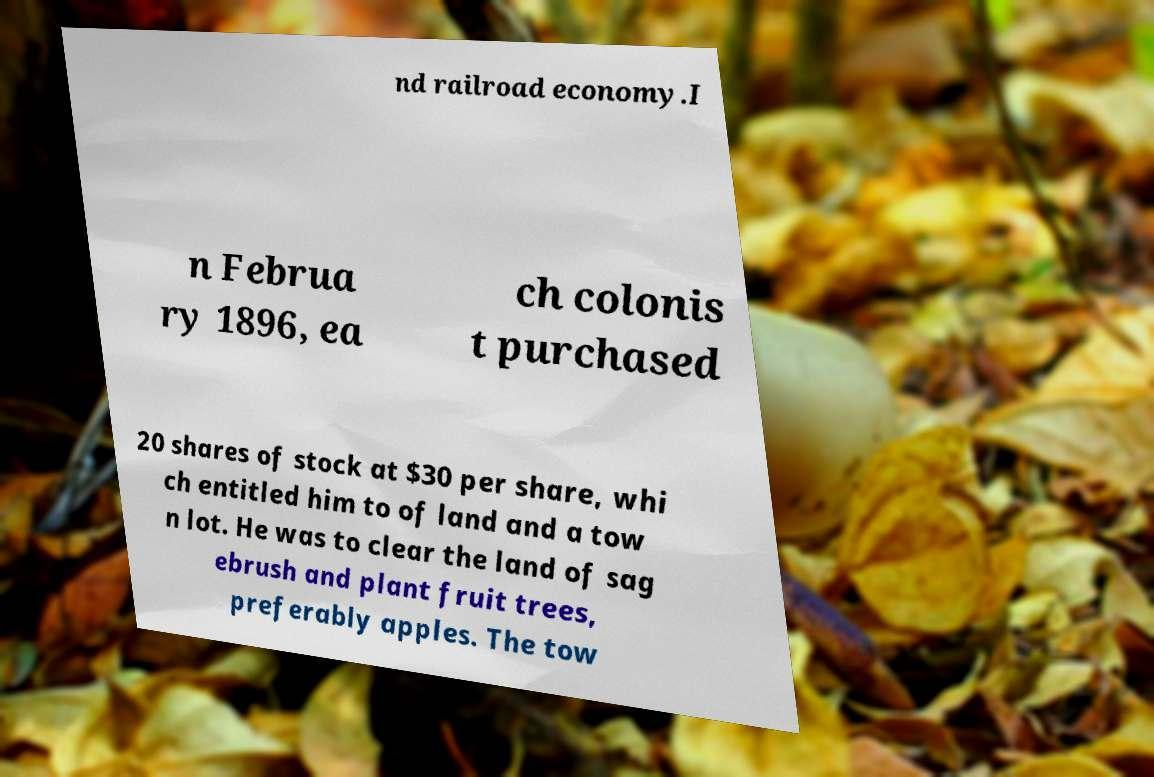I need the written content from this picture converted into text. Can you do that? nd railroad economy.I n Februa ry 1896, ea ch colonis t purchased 20 shares of stock at $30 per share, whi ch entitled him to of land and a tow n lot. He was to clear the land of sag ebrush and plant fruit trees, preferably apples. The tow 